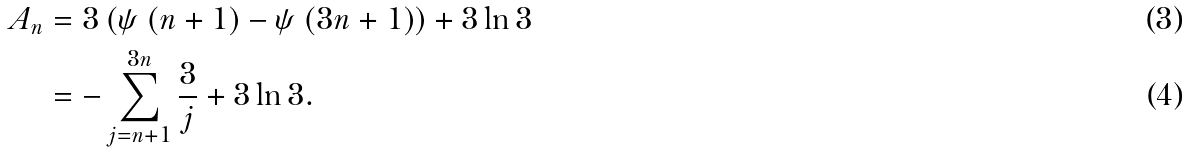Convert formula to latex. <formula><loc_0><loc_0><loc_500><loc_500>A _ { n } & = 3 \left ( \psi \left ( n + 1 \right ) - \psi \left ( 3 n + 1 \right ) \right ) + 3 \ln 3 \\ & = - \sum _ { j = n + 1 } ^ { 3 n } \frac { 3 } { j } + 3 \ln 3 .</formula> 